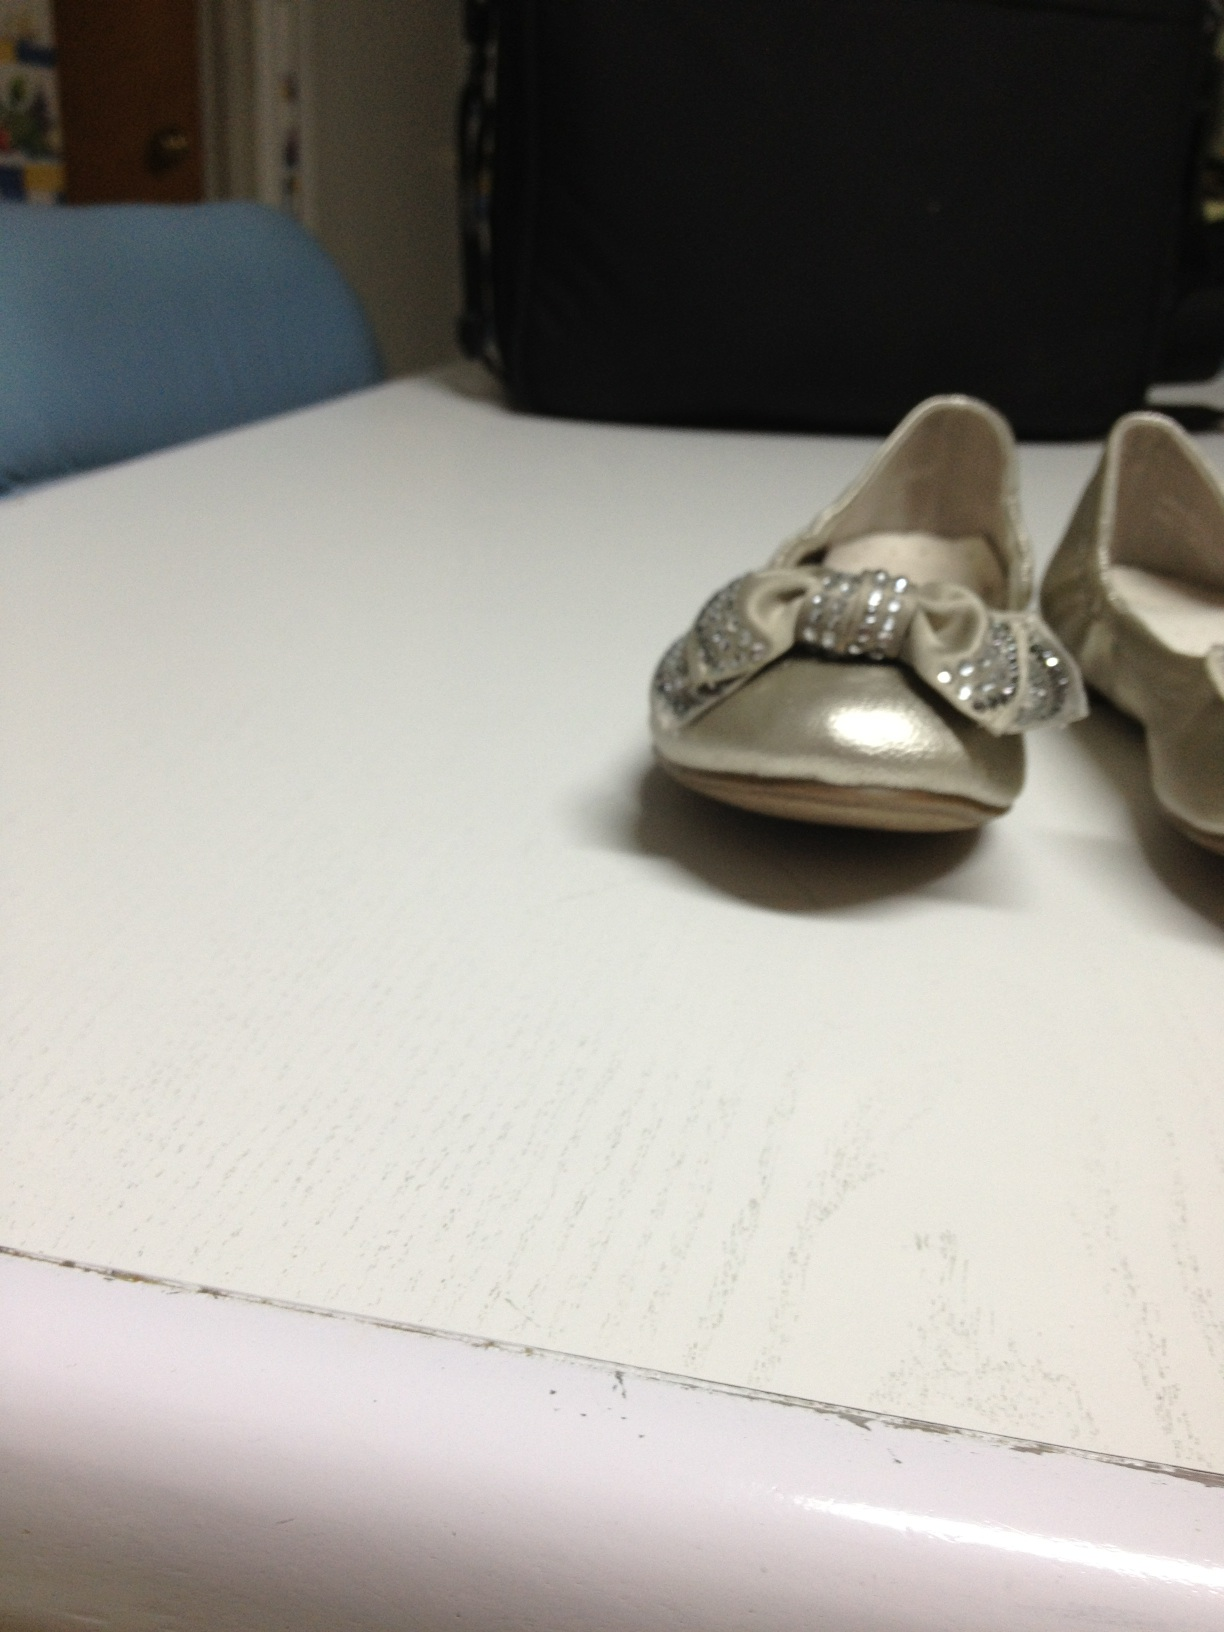What do you think about the design of these shoes? The design of these shoes is quite charming and elegant. The silver color combined with the sparkling bows gives them a festive and formal look. They seem perfect for special occasions and could easily complement a fancy dress or outfit, adding a delightful touch of glamour. 